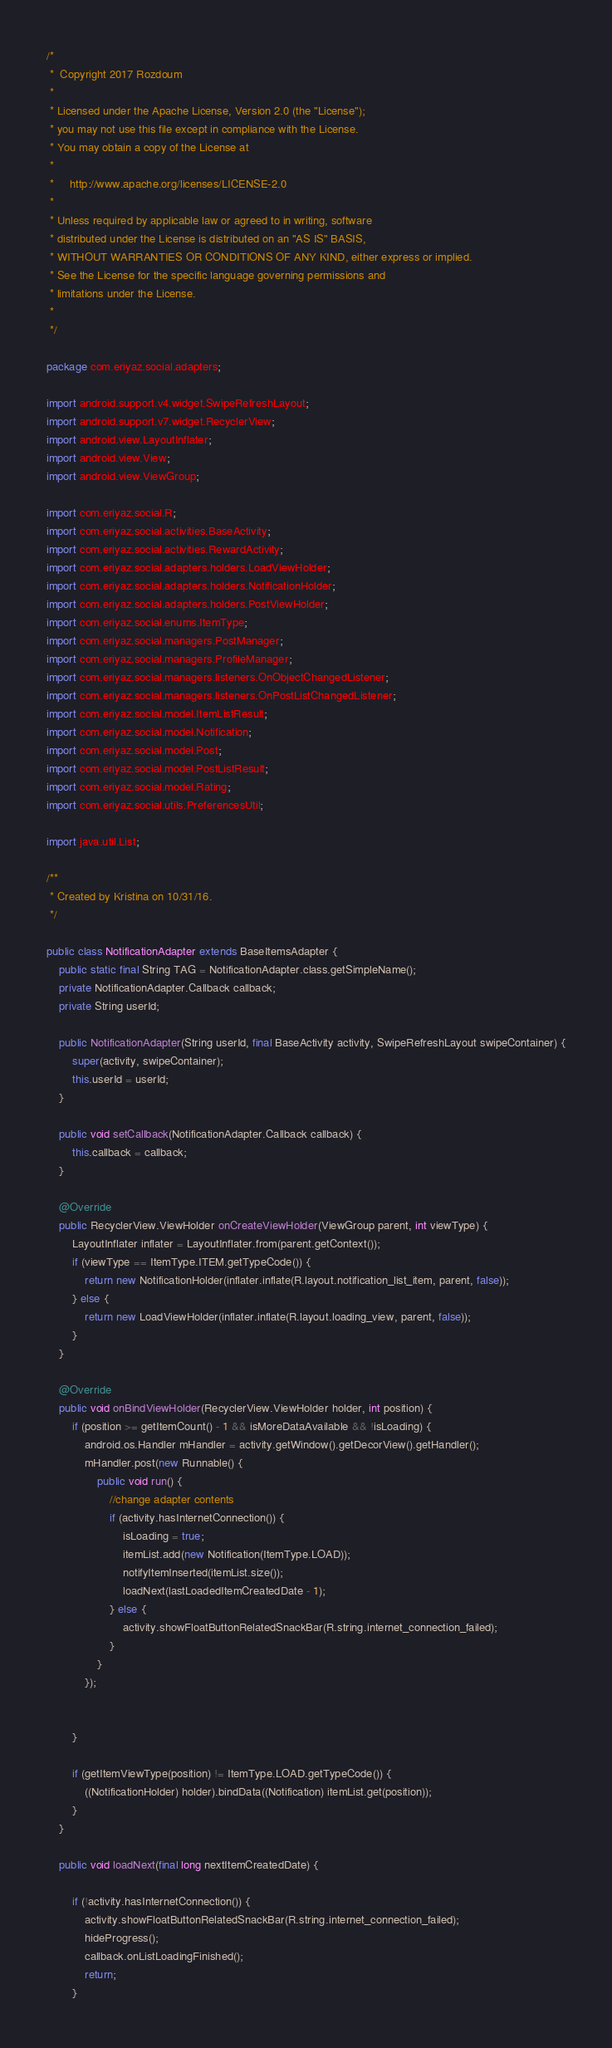Convert code to text. <code><loc_0><loc_0><loc_500><loc_500><_Java_>/*
 *  Copyright 2017 Rozdoum
 *
 * Licensed under the Apache License, Version 2.0 (the "License");
 * you may not use this file except in compliance with the License.
 * You may obtain a copy of the License at
 *
 *     http://www.apache.org/licenses/LICENSE-2.0
 *
 * Unless required by applicable law or agreed to in writing, software
 * distributed under the License is distributed on an "AS IS" BASIS,
 * WITHOUT WARRANTIES OR CONDITIONS OF ANY KIND, either express or implied.
 * See the License for the specific language governing permissions and
 * limitations under the License.
 *
 */

package com.eriyaz.social.adapters;

import android.support.v4.widget.SwipeRefreshLayout;
import android.support.v7.widget.RecyclerView;
import android.view.LayoutInflater;
import android.view.View;
import android.view.ViewGroup;

import com.eriyaz.social.R;
import com.eriyaz.social.activities.BaseActivity;
import com.eriyaz.social.activities.RewardActivity;
import com.eriyaz.social.adapters.holders.LoadViewHolder;
import com.eriyaz.social.adapters.holders.NotificationHolder;
import com.eriyaz.social.adapters.holders.PostViewHolder;
import com.eriyaz.social.enums.ItemType;
import com.eriyaz.social.managers.PostManager;
import com.eriyaz.social.managers.ProfileManager;
import com.eriyaz.social.managers.listeners.OnObjectChangedListener;
import com.eriyaz.social.managers.listeners.OnPostListChangedListener;
import com.eriyaz.social.model.ItemListResult;
import com.eriyaz.social.model.Notification;
import com.eriyaz.social.model.Post;
import com.eriyaz.social.model.PostListResult;
import com.eriyaz.social.model.Rating;
import com.eriyaz.social.utils.PreferencesUtil;

import java.util.List;

/**
 * Created by Kristina on 10/31/16.
 */

public class NotificationAdapter extends BaseItemsAdapter {
    public static final String TAG = NotificationAdapter.class.getSimpleName();
    private NotificationAdapter.Callback callback;
    private String userId;

    public NotificationAdapter(String userId, final BaseActivity activity, SwipeRefreshLayout swipeContainer) {
        super(activity, swipeContainer);
        this.userId = userId;
    }

    public void setCallback(NotificationAdapter.Callback callback) {
        this.callback = callback;
    }

    @Override
    public RecyclerView.ViewHolder onCreateViewHolder(ViewGroup parent, int viewType) {
        LayoutInflater inflater = LayoutInflater.from(parent.getContext());
        if (viewType == ItemType.ITEM.getTypeCode()) {
            return new NotificationHolder(inflater.inflate(R.layout.notification_list_item, parent, false));
        } else {
            return new LoadViewHolder(inflater.inflate(R.layout.loading_view, parent, false));
        }
    }

    @Override
    public void onBindViewHolder(RecyclerView.ViewHolder holder, int position) {
        if (position >= getItemCount() - 1 && isMoreDataAvailable && !isLoading) {
            android.os.Handler mHandler = activity.getWindow().getDecorView().getHandler();
            mHandler.post(new Runnable() {
                public void run() {
                    //change adapter contents
                    if (activity.hasInternetConnection()) {
                        isLoading = true;
                        itemList.add(new Notification(ItemType.LOAD));
                        notifyItemInserted(itemList.size());
                        loadNext(lastLoadedItemCreatedDate - 1);
                    } else {
                        activity.showFloatButtonRelatedSnackBar(R.string.internet_connection_failed);
                    }
                }
            });


        }

        if (getItemViewType(position) != ItemType.LOAD.getTypeCode()) {
            ((NotificationHolder) holder).bindData((Notification) itemList.get(position));
        }
    }

    public void loadNext(final long nextItemCreatedDate) {

        if (!activity.hasInternetConnection()) {
            activity.showFloatButtonRelatedSnackBar(R.string.internet_connection_failed);
            hideProgress();
            callback.onListLoadingFinished();
            return;
        }
</code> 